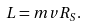Convert formula to latex. <formula><loc_0><loc_0><loc_500><loc_500>L = m v R _ { S } .</formula> 